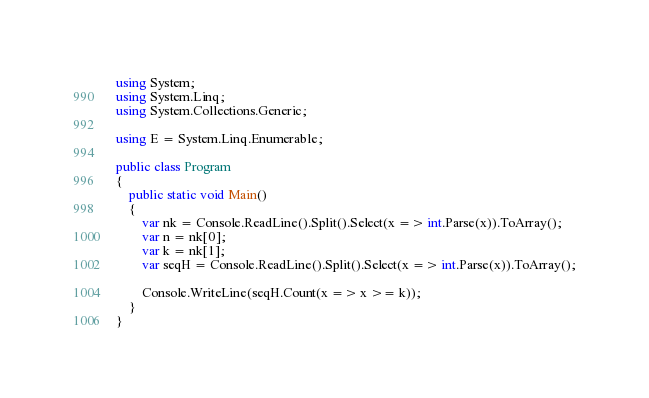Convert code to text. <code><loc_0><loc_0><loc_500><loc_500><_C#_>using System;
using System.Linq;
using System.Collections.Generic;

using E = System.Linq.Enumerable;

public class Program
{
    public static void Main()
    {
        var nk = Console.ReadLine().Split().Select(x => int.Parse(x)).ToArray();
        var n = nk[0];
        var k = nk[1];
        var seqH = Console.ReadLine().Split().Select(x => int.Parse(x)).ToArray();

        Console.WriteLine(seqH.Count(x => x >= k));
    }
}
</code> 